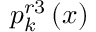Convert formula to latex. <formula><loc_0><loc_0><loc_500><loc_500>p _ { k } ^ { r 3 } \left ( x \right )</formula> 